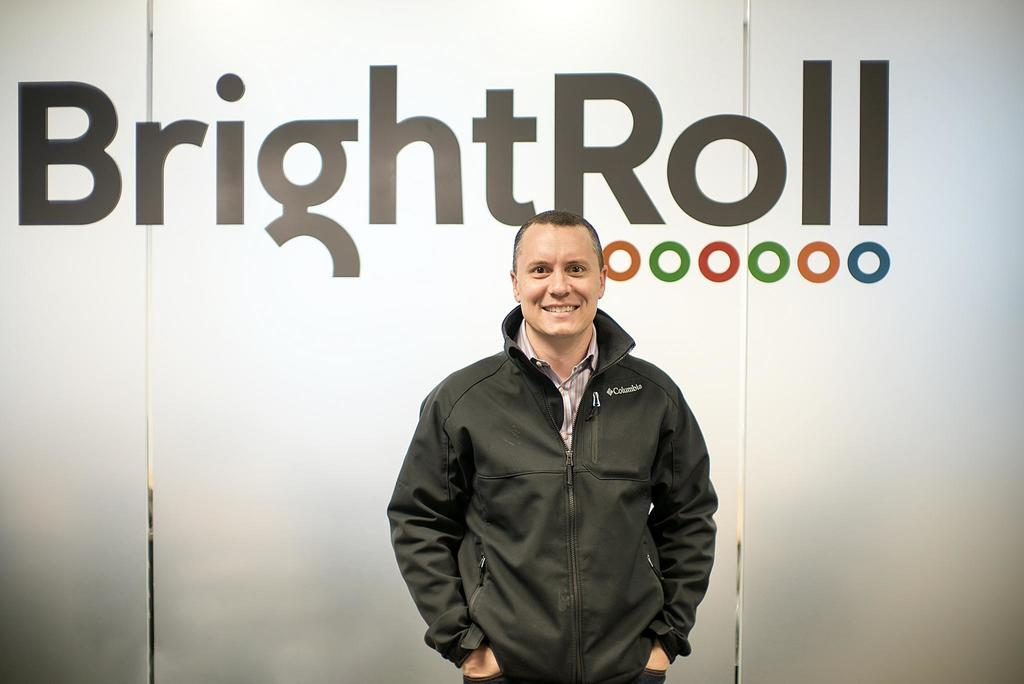What is the main subject in the foreground of the image? There is a person standing in the foreground of the image. What is the person standing on? The person is standing on the floor. What can be seen in the background of the image? There is a wall in the background of the image. What is written or depicted on the wall? There is text on the wall. What type of location might the image have been taken in? The image may have been taken in a hall. What type of disease is the person in the image suffering from? There is no indication of any disease in the image, and we cannot make assumptions about the person's health. Can you tell me the age of the girl in the image? There is no girl present in the image, only a person standing in the foreground. 